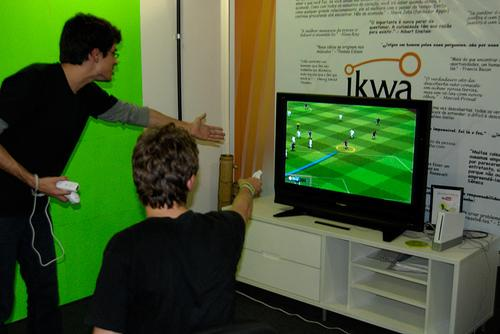What do these young people pretend to do? Please explain your reasoning. play soccer. There are many athletes on the screen so it must be a team sport. 